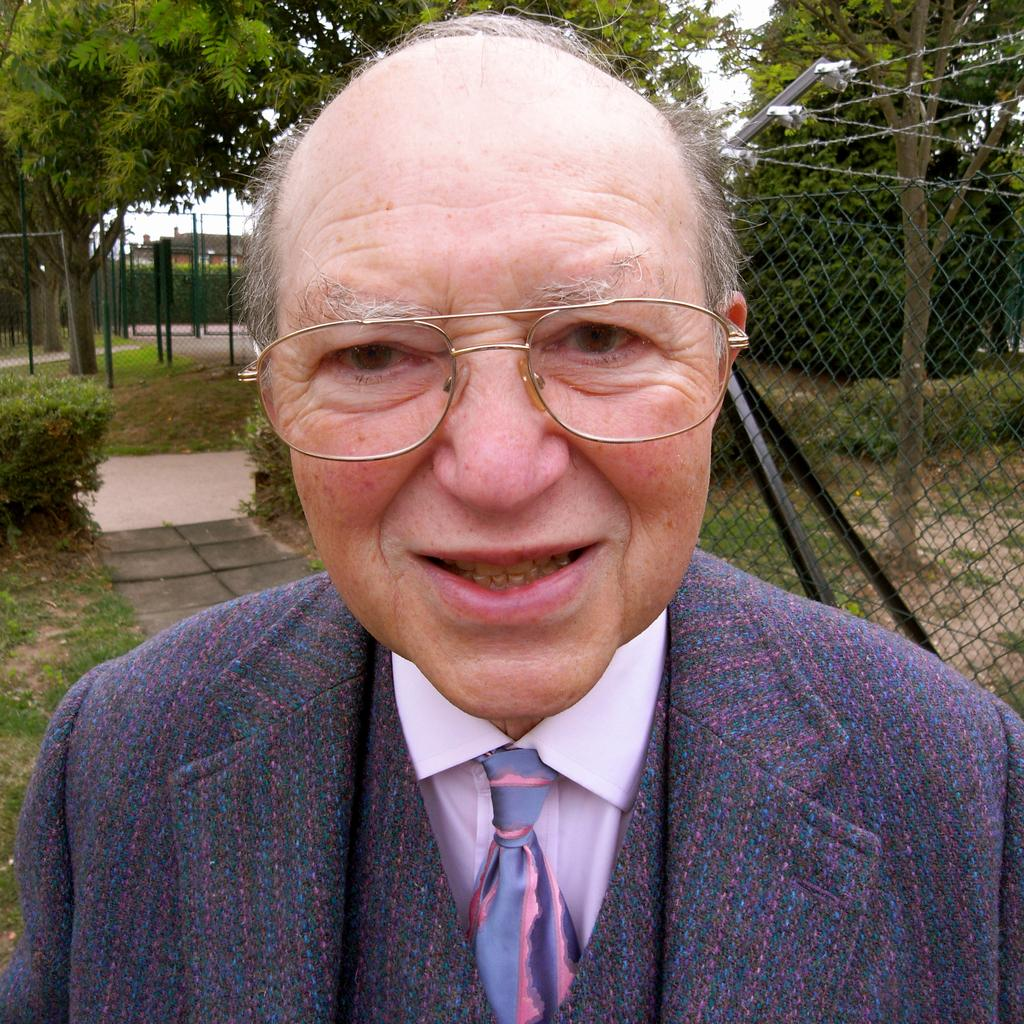What type of person is in the image? There is an old man in the image. What accessories is the old man wearing? The old man is wearing specs, a tie, a shirt, and a blazer. What can be seen in the background of the image? There is fencing, wires, trees, and bushes in the background of the image. What type of machine is being used by the crow in the image? There is no crow or machine present in the image. What type of meal is the old man eating in the image? There is no meal present in the image; the old man is not eating anything. 